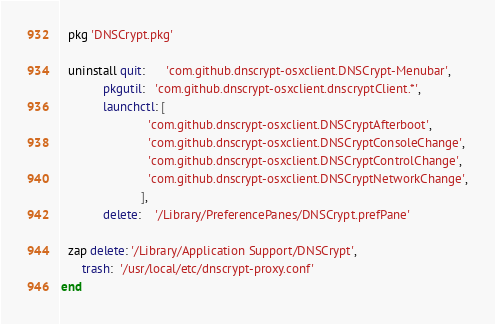Convert code to text. <code><loc_0><loc_0><loc_500><loc_500><_Ruby_>  pkg 'DNSCrypt.pkg'

  uninstall quit:      'com.github.dnscrypt-osxclient.DNSCrypt-Menubar',
            pkgutil:   'com.github.dnscrypt-osxclient.dnscryptClient.*',
            launchctl: [
                         'com.github.dnscrypt-osxclient.DNSCryptAfterboot',
                         'com.github.dnscrypt-osxclient.DNSCryptConsoleChange',
                         'com.github.dnscrypt-osxclient.DNSCryptControlChange',
                         'com.github.dnscrypt-osxclient.DNSCryptNetworkChange',
                       ],
            delete:    '/Library/PreferencePanes/DNSCrypt.prefPane'

  zap delete: '/Library/Application Support/DNSCrypt',
      trash:  '/usr/local/etc/dnscrypt-proxy.conf'
end
</code> 